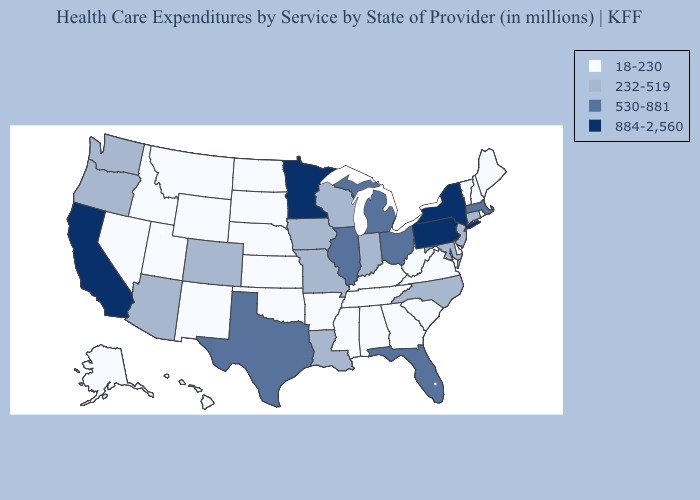Which states hav the highest value in the West?
Quick response, please. California. Among the states that border Idaho , does Nevada have the highest value?
Concise answer only. No. What is the value of Missouri?
Short answer required. 232-519. Which states have the highest value in the USA?
Be succinct. California, Minnesota, New York, Pennsylvania. Among the states that border Wisconsin , does Michigan have the highest value?
Short answer required. No. Is the legend a continuous bar?
Be succinct. No. Name the states that have a value in the range 884-2,560?
Write a very short answer. California, Minnesota, New York, Pennsylvania. Which states hav the highest value in the South?
Quick response, please. Florida, Texas. Name the states that have a value in the range 530-881?
Answer briefly. Florida, Illinois, Massachusetts, Michigan, Ohio, Texas. What is the highest value in the USA?
Write a very short answer. 884-2,560. What is the value of Missouri?
Write a very short answer. 232-519. Does North Carolina have the lowest value in the USA?
Quick response, please. No. What is the value of Georgia?
Short answer required. 18-230. What is the highest value in the USA?
Answer briefly. 884-2,560. What is the value of Maine?
Answer briefly. 18-230. 